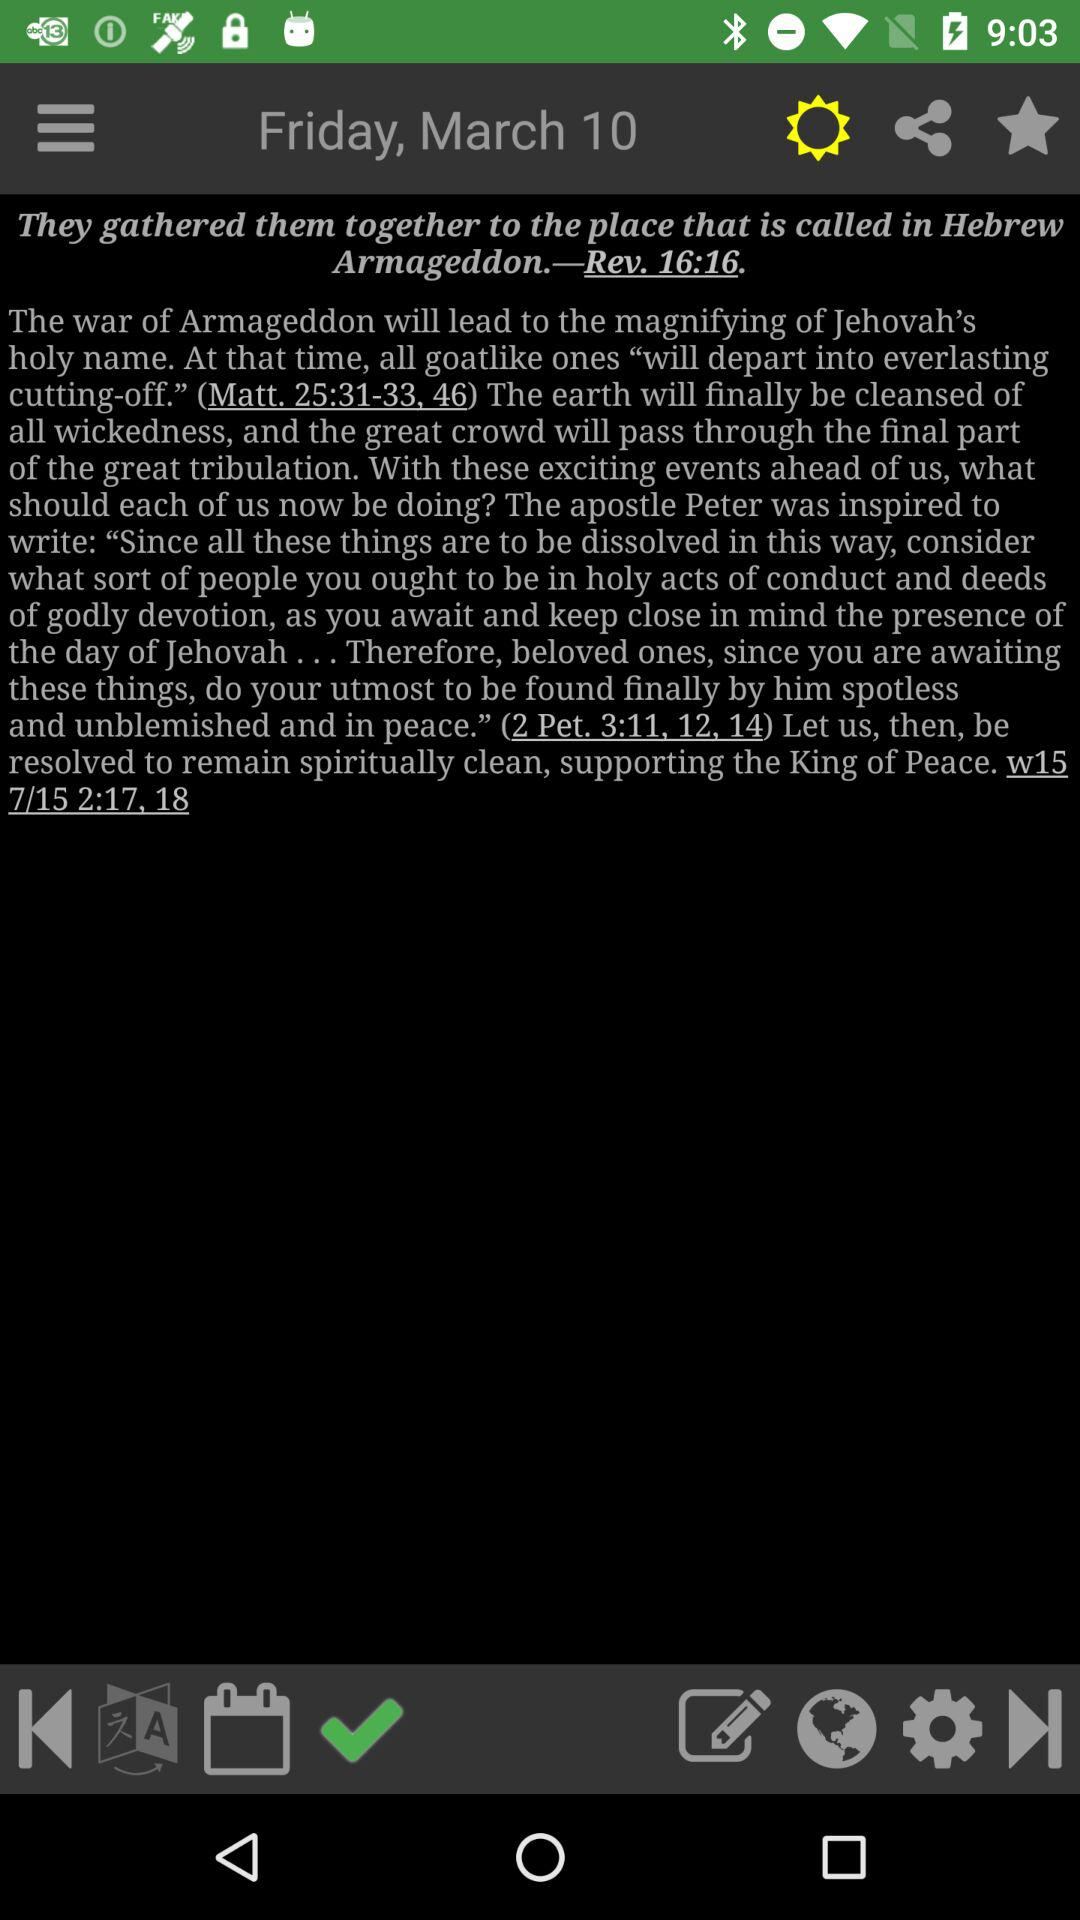What is the date? The date is Friday, March 10. 